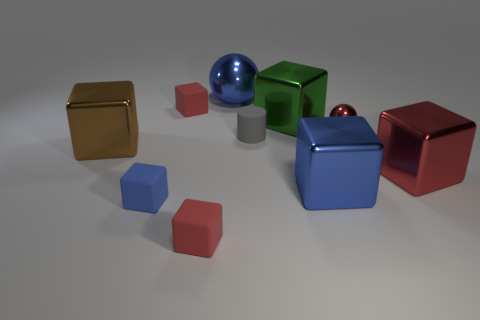There is a tiny metal thing; does it have the same color as the matte cube behind the gray cylinder?
Make the answer very short. Yes. The matte thing that is both behind the blue metal block and in front of the big green thing has what shape?
Make the answer very short. Cylinder. Are there fewer blue blocks than small blue objects?
Offer a very short reply. No. Are there any gray metallic blocks?
Provide a succinct answer. No. How many other things are the same size as the cylinder?
Provide a short and direct response. 4. Does the brown cube have the same material as the small red object that is right of the green metal thing?
Provide a short and direct response. Yes. Is the number of large green things on the left side of the large green metal block the same as the number of tiny blue matte cubes behind the small blue matte block?
Provide a succinct answer. Yes. What material is the blue sphere?
Keep it short and to the point. Metal. There is a shiny object that is the same size as the matte cylinder; what color is it?
Your response must be concise. Red. There is a block that is on the left side of the blue rubber thing; are there any cylinders that are right of it?
Your answer should be very brief. Yes. 